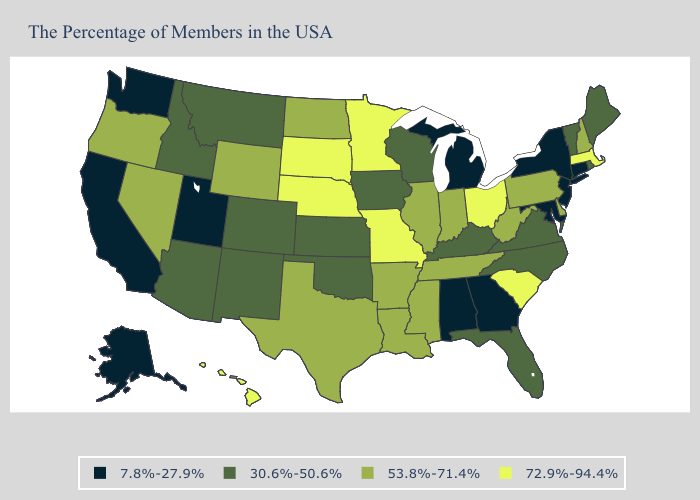What is the highest value in the USA?
Give a very brief answer. 72.9%-94.4%. Does Rhode Island have the lowest value in the Northeast?
Quick response, please. No. What is the value of Alabama?
Give a very brief answer. 7.8%-27.9%. Among the states that border Michigan , which have the highest value?
Write a very short answer. Ohio. Does the first symbol in the legend represent the smallest category?
Be succinct. Yes. Does New York have the lowest value in the Northeast?
Answer briefly. Yes. Name the states that have a value in the range 53.8%-71.4%?
Quick response, please. New Hampshire, Delaware, Pennsylvania, West Virginia, Indiana, Tennessee, Illinois, Mississippi, Louisiana, Arkansas, Texas, North Dakota, Wyoming, Nevada, Oregon. What is the value of Oregon?
Answer briefly. 53.8%-71.4%. What is the lowest value in states that border Illinois?
Give a very brief answer. 30.6%-50.6%. Does the map have missing data?
Give a very brief answer. No. Does California have a higher value than Illinois?
Give a very brief answer. No. What is the value of Hawaii?
Quick response, please. 72.9%-94.4%. Does Ohio have the lowest value in the MidWest?
Give a very brief answer. No. Among the states that border California , which have the highest value?
Be succinct. Nevada, Oregon. 